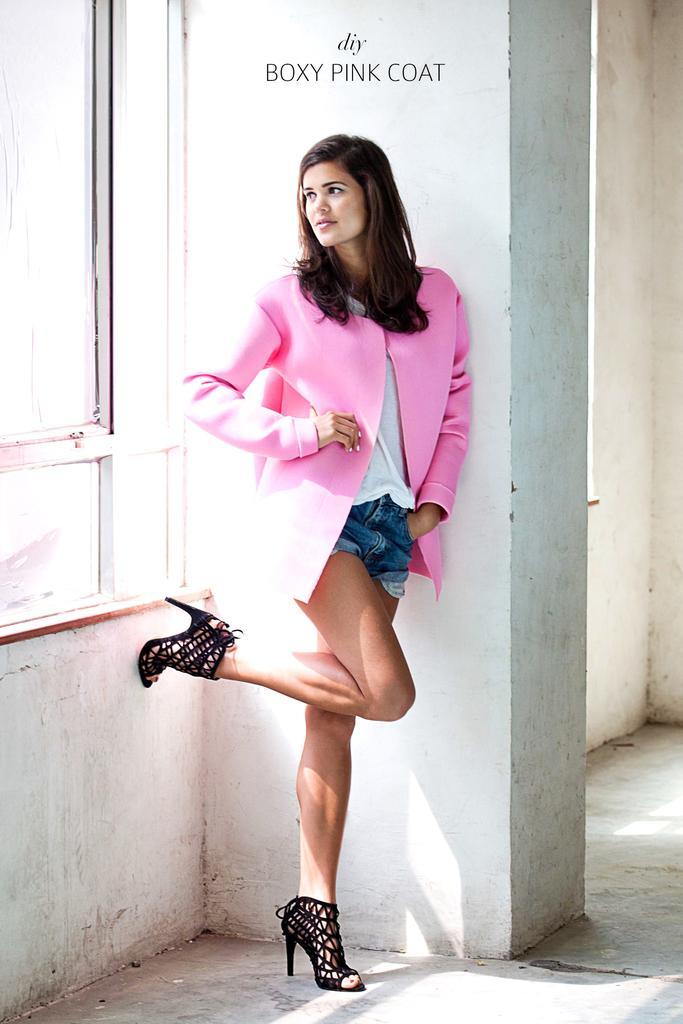In one or two sentences, can you explain what this image depicts? In this image I can see a woman wearing pink, white and blue colored dress is standing on the floor. I can see a window to the left side of the image and something is written at the top of the image. 